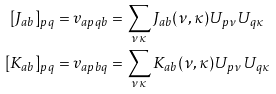Convert formula to latex. <formula><loc_0><loc_0><loc_500><loc_500>[ J _ { a b } ] _ { p q } & = v _ { a p q b } = \sum _ { \nu \kappa } J _ { a b } ( \nu , \kappa ) U _ { p \nu } U _ { q \kappa } \\ [ K _ { a b } ] _ { p q } & = v _ { a p b q } = \sum _ { \nu \kappa } K _ { a b } ( \nu , \kappa ) U _ { p \nu } U _ { q \kappa }</formula> 